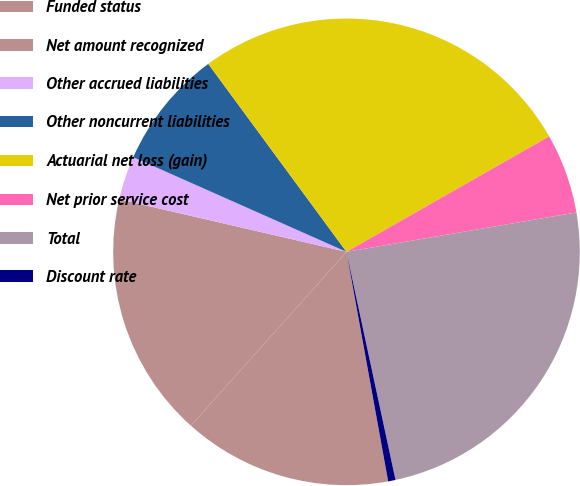<chart> <loc_0><loc_0><loc_500><loc_500><pie_chart><fcel>Funded status<fcel>Net amount recognized<fcel>Other accrued liabilities<fcel>Other noncurrent liabilities<fcel>Actuarial net loss (gain)<fcel>Net prior service cost<fcel>Total<fcel>Discount rate<nl><fcel>14.48%<fcel>17.0%<fcel>3.03%<fcel>8.26%<fcel>26.85%<fcel>5.54%<fcel>24.33%<fcel>0.51%<nl></chart> 